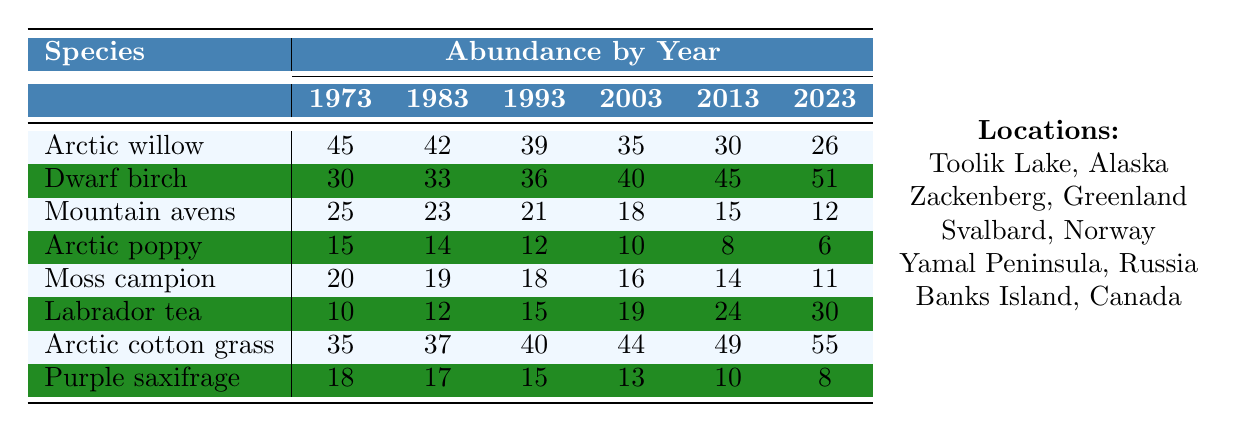What is the abundance of Arctic willow in 2023? The table shows the abundance of Arctic willow as 26 in the year 2023.
Answer: 26 Which plant species had the highest abundance in 2003? The abundance values in 2003 are Arctic willow (35), Dwarf birch (40), Mountain avens (18), Arctic poppy (10), Moss campion (16), Labrador tea (19), Arctic cotton grass (44), and Purple saxifrage (13). The highest is Arctic cotton grass with 44.
Answer: Arctic cotton grass What was the change in abundance of Arctic poppy from 1973 to 2023? The abundance of Arctic poppy in 1973 was 15, and in 2023 it decreased to 6. The change is 15 - 6 = 9, indicating a decline.
Answer: Decrease of 9 What is the average abundance of Labrador tea over the years? The abundance values for Labrador tea are 10, 12, 15, 19, 24, 30. Summing them gives (10 + 12 + 15 + 19 + 24 + 30) = 110. There are 6 values, so the average is 110/6 = 18.33.
Answer: 18.33 Did the abundance of Mountain avens increase or decrease from 1973 to 2023? The abundance of Mountain avens decreased from 25 in 1973 to 12 in 2023. Therefore, it decreased.
Answer: Decreased Which species showed a consistent increase in abundance over the years? Reviewing the table, Dwarf birch and Arctic cotton grass show increases over the years, with Dwarf birch moving from 30 to 51 and Arctic cotton grass from 35 to 55.
Answer: Dwarf birch and Arctic cotton grass What was the overall trend for Arctic willow from 1973 to 2023? The abundance of Arctic willow decreased from 45 in 1973 to 26 in 2023. This indicates a declining trend over the 50 years.
Answer: Declining trend Calculate the difference in abundance between the highest and lowest species in 2023. In 2023, the highest abundance is Arctic cotton grass (55) and the lowest is Arctic poppy (6). The difference is 55 - 6 = 49.
Answer: 49 What species had the lowest abundance in the year 2013? The species abundance in 2013 shows Arctic poppy with 8 as the lowest.
Answer: Arctic poppy Did any species experience an increase in abundance from 1993 to 2023? Comparing the years, Labrador tea increased from 15 in 1993 to 30 in 2023, indicating an increase.
Answer: Yes, Labrador tea Which species had the largest decline in abundance from 1973 to 2023? The abundances show that Mountain avens fell from 25 to 12, which is a decline of 13. The largest decline is Arctic poppy from 15 to 6, a decline of 9.
Answer: Mountain avens (decline of 13) 